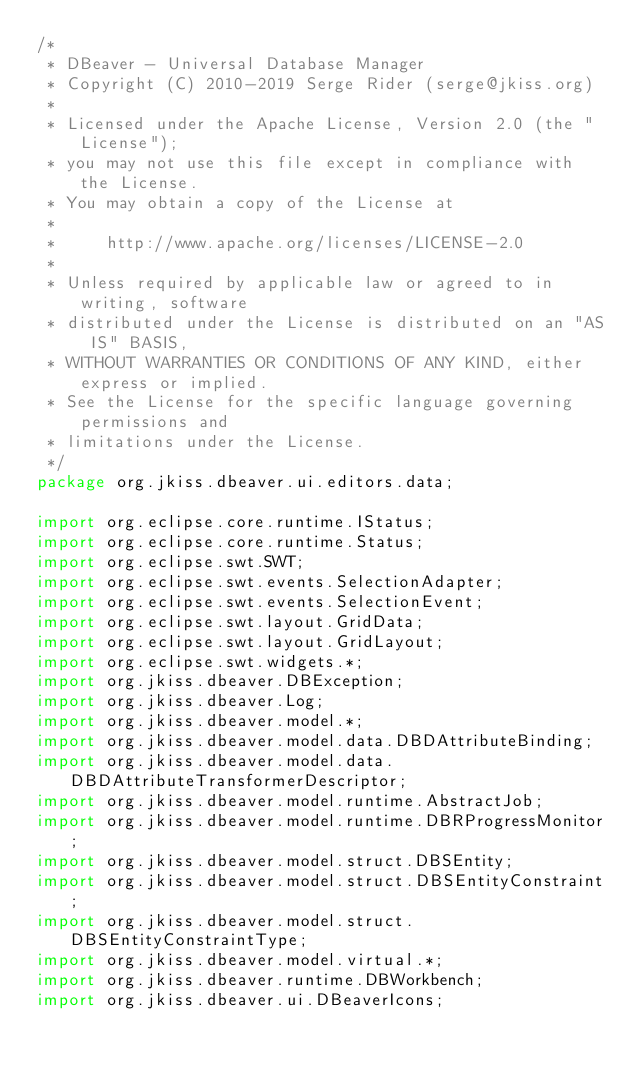Convert code to text. <code><loc_0><loc_0><loc_500><loc_500><_Java_>/*
 * DBeaver - Universal Database Manager
 * Copyright (C) 2010-2019 Serge Rider (serge@jkiss.org)
 *
 * Licensed under the Apache License, Version 2.0 (the "License");
 * you may not use this file except in compliance with the License.
 * You may obtain a copy of the License at
 *
 *     http://www.apache.org/licenses/LICENSE-2.0
 *
 * Unless required by applicable law or agreed to in writing, software
 * distributed under the License is distributed on an "AS IS" BASIS,
 * WITHOUT WARRANTIES OR CONDITIONS OF ANY KIND, either express or implied.
 * See the License for the specific language governing permissions and
 * limitations under the License.
 */
package org.jkiss.dbeaver.ui.editors.data;

import org.eclipse.core.runtime.IStatus;
import org.eclipse.core.runtime.Status;
import org.eclipse.swt.SWT;
import org.eclipse.swt.events.SelectionAdapter;
import org.eclipse.swt.events.SelectionEvent;
import org.eclipse.swt.layout.GridData;
import org.eclipse.swt.layout.GridLayout;
import org.eclipse.swt.widgets.*;
import org.jkiss.dbeaver.DBException;
import org.jkiss.dbeaver.Log;
import org.jkiss.dbeaver.model.*;
import org.jkiss.dbeaver.model.data.DBDAttributeBinding;
import org.jkiss.dbeaver.model.data.DBDAttributeTransformerDescriptor;
import org.jkiss.dbeaver.model.runtime.AbstractJob;
import org.jkiss.dbeaver.model.runtime.DBRProgressMonitor;
import org.jkiss.dbeaver.model.struct.DBSEntity;
import org.jkiss.dbeaver.model.struct.DBSEntityConstraint;
import org.jkiss.dbeaver.model.struct.DBSEntityConstraintType;
import org.jkiss.dbeaver.model.virtual.*;
import org.jkiss.dbeaver.runtime.DBWorkbench;
import org.jkiss.dbeaver.ui.DBeaverIcons;</code> 